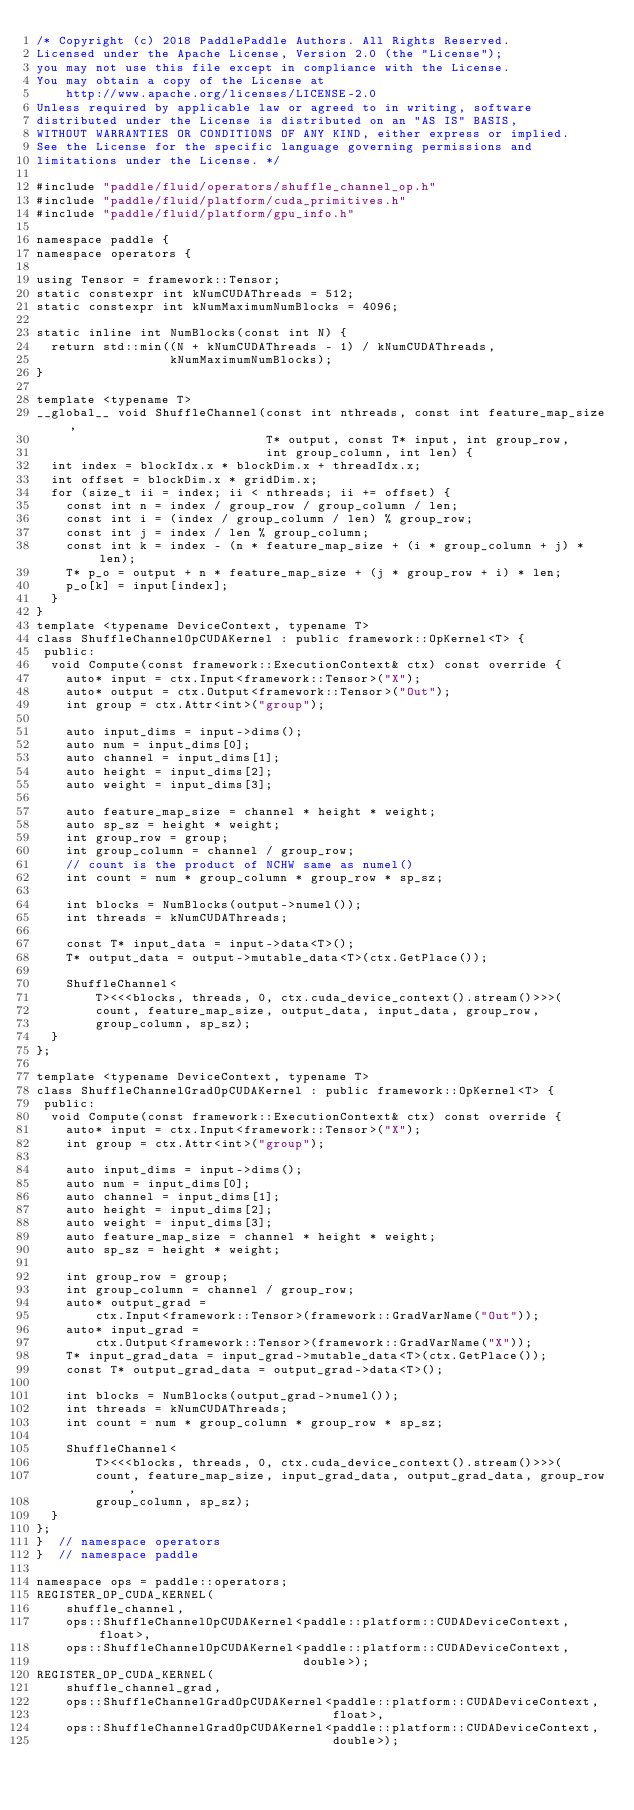<code> <loc_0><loc_0><loc_500><loc_500><_Cuda_>/* Copyright (c) 2018 PaddlePaddle Authors. All Rights Reserved.
Licensed under the Apache License, Version 2.0 (the "License");
you may not use this file except in compliance with the License.
You may obtain a copy of the License at
    http://www.apache.org/licenses/LICENSE-2.0
Unless required by applicable law or agreed to in writing, software
distributed under the License is distributed on an "AS IS" BASIS,
WITHOUT WARRANTIES OR CONDITIONS OF ANY KIND, either express or implied.
See the License for the specific language governing permissions and
limitations under the License. */

#include "paddle/fluid/operators/shuffle_channel_op.h"
#include "paddle/fluid/platform/cuda_primitives.h"
#include "paddle/fluid/platform/gpu_info.h"

namespace paddle {
namespace operators {

using Tensor = framework::Tensor;
static constexpr int kNumCUDAThreads = 512;
static constexpr int kNumMaximumNumBlocks = 4096;

static inline int NumBlocks(const int N) {
  return std::min((N + kNumCUDAThreads - 1) / kNumCUDAThreads,
                  kNumMaximumNumBlocks);
}

template <typename T>
__global__ void ShuffleChannel(const int nthreads, const int feature_map_size,
                               T* output, const T* input, int group_row,
                               int group_column, int len) {
  int index = blockIdx.x * blockDim.x + threadIdx.x;
  int offset = blockDim.x * gridDim.x;
  for (size_t ii = index; ii < nthreads; ii += offset) {
    const int n = index / group_row / group_column / len;
    const int i = (index / group_column / len) % group_row;
    const int j = index / len % group_column;
    const int k = index - (n * feature_map_size + (i * group_column + j) * len);
    T* p_o = output + n * feature_map_size + (j * group_row + i) * len;
    p_o[k] = input[index];
  }
}
template <typename DeviceContext, typename T>
class ShuffleChannelOpCUDAKernel : public framework::OpKernel<T> {
 public:
  void Compute(const framework::ExecutionContext& ctx) const override {
    auto* input = ctx.Input<framework::Tensor>("X");
    auto* output = ctx.Output<framework::Tensor>("Out");
    int group = ctx.Attr<int>("group");

    auto input_dims = input->dims();
    auto num = input_dims[0];
    auto channel = input_dims[1];
    auto height = input_dims[2];
    auto weight = input_dims[3];

    auto feature_map_size = channel * height * weight;
    auto sp_sz = height * weight;
    int group_row = group;
    int group_column = channel / group_row;
    // count is the product of NCHW same as numel()
    int count = num * group_column * group_row * sp_sz;

    int blocks = NumBlocks(output->numel());
    int threads = kNumCUDAThreads;

    const T* input_data = input->data<T>();
    T* output_data = output->mutable_data<T>(ctx.GetPlace());

    ShuffleChannel<
        T><<<blocks, threads, 0, ctx.cuda_device_context().stream()>>>(
        count, feature_map_size, output_data, input_data, group_row,
        group_column, sp_sz);
  }
};

template <typename DeviceContext, typename T>
class ShuffleChannelGradOpCUDAKernel : public framework::OpKernel<T> {
 public:
  void Compute(const framework::ExecutionContext& ctx) const override {
    auto* input = ctx.Input<framework::Tensor>("X");
    int group = ctx.Attr<int>("group");

    auto input_dims = input->dims();
    auto num = input_dims[0];
    auto channel = input_dims[1];
    auto height = input_dims[2];
    auto weight = input_dims[3];
    auto feature_map_size = channel * height * weight;
    auto sp_sz = height * weight;

    int group_row = group;
    int group_column = channel / group_row;
    auto* output_grad =
        ctx.Input<framework::Tensor>(framework::GradVarName("Out"));
    auto* input_grad =
        ctx.Output<framework::Tensor>(framework::GradVarName("X"));
    T* input_grad_data = input_grad->mutable_data<T>(ctx.GetPlace());
    const T* output_grad_data = output_grad->data<T>();

    int blocks = NumBlocks(output_grad->numel());
    int threads = kNumCUDAThreads;
    int count = num * group_column * group_row * sp_sz;

    ShuffleChannel<
        T><<<blocks, threads, 0, ctx.cuda_device_context().stream()>>>(
        count, feature_map_size, input_grad_data, output_grad_data, group_row,
        group_column, sp_sz);
  }
};
}  // namespace operators
}  // namespace paddle

namespace ops = paddle::operators;
REGISTER_OP_CUDA_KERNEL(
    shuffle_channel,
    ops::ShuffleChannelOpCUDAKernel<paddle::platform::CUDADeviceContext, float>,
    ops::ShuffleChannelOpCUDAKernel<paddle::platform::CUDADeviceContext,
                                    double>);
REGISTER_OP_CUDA_KERNEL(
    shuffle_channel_grad,
    ops::ShuffleChannelGradOpCUDAKernel<paddle::platform::CUDADeviceContext,
                                        float>,
    ops::ShuffleChannelGradOpCUDAKernel<paddle::platform::CUDADeviceContext,
                                        double>);
</code> 